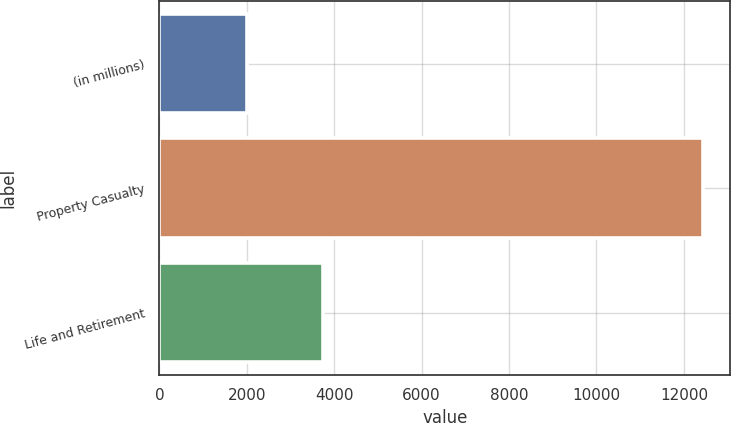Convert chart to OTSL. <chart><loc_0><loc_0><loc_500><loc_500><bar_chart><fcel>(in millions)<fcel>Property Casualty<fcel>Life and Retirement<nl><fcel>2013<fcel>12441<fcel>3741<nl></chart> 